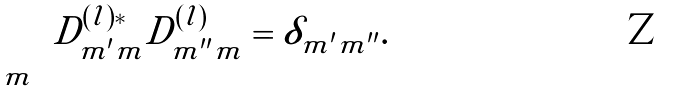Convert formula to latex. <formula><loc_0><loc_0><loc_500><loc_500>\sum _ { m } D _ { m ^ { \prime } m } ^ { ( l ) * } D _ { m ^ { \prime \prime } m } ^ { ( l ) } = \delta _ { m ^ { \prime } m ^ { \prime \prime } } .</formula> 